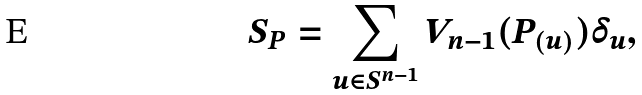<formula> <loc_0><loc_0><loc_500><loc_500>S _ { P } = \sum _ { u \in S ^ { n - 1 } } V _ { n - 1 } ( P _ { ( u ) } ) \delta _ { u } ,</formula> 